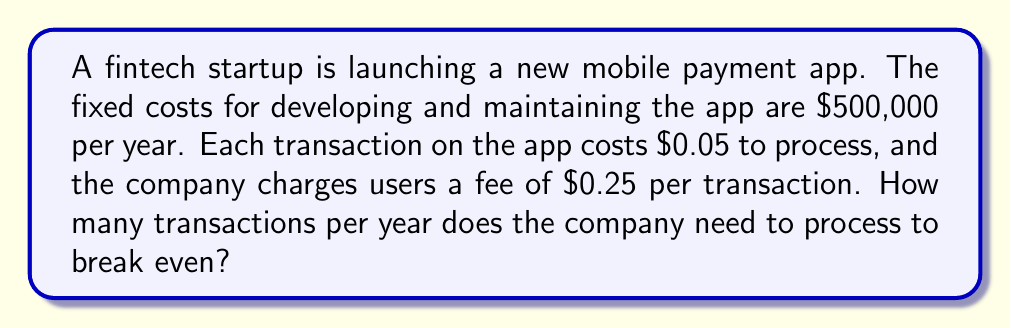Help me with this question. To solve this problem, we need to use the break-even formula:

$$\text{Break-even point} = \frac{\text{Fixed Costs}}{\text{Price per unit - Variable Cost per unit}}$$

Let's identify the components:

1. Fixed Costs (FC) = $500,000 per year
2. Price per unit (P) = $0.25 per transaction
3. Variable Cost per unit (VC) = $0.05 per transaction

Now, let's plug these values into the formula:

$$\text{Break-even point} = \frac{500,000}{0.25 - 0.05}$$

$$\text{Break-even point} = \frac{500,000}{0.20}$$

$$\text{Break-even point} = 2,500,000$$

Therefore, the company needs to process 2,500,000 transactions per year to break even.

To verify:
Revenue = 2,500,000 × $0.25 = $625,000
Variable Costs = 2,500,000 × $0.05 = $125,000
Fixed Costs = $500,000

Total Costs = Variable Costs + Fixed Costs = $125,000 + $500,000 = $625,000

Revenue = Total Costs, confirming the break-even point.
Answer: 2,500,000 transactions 